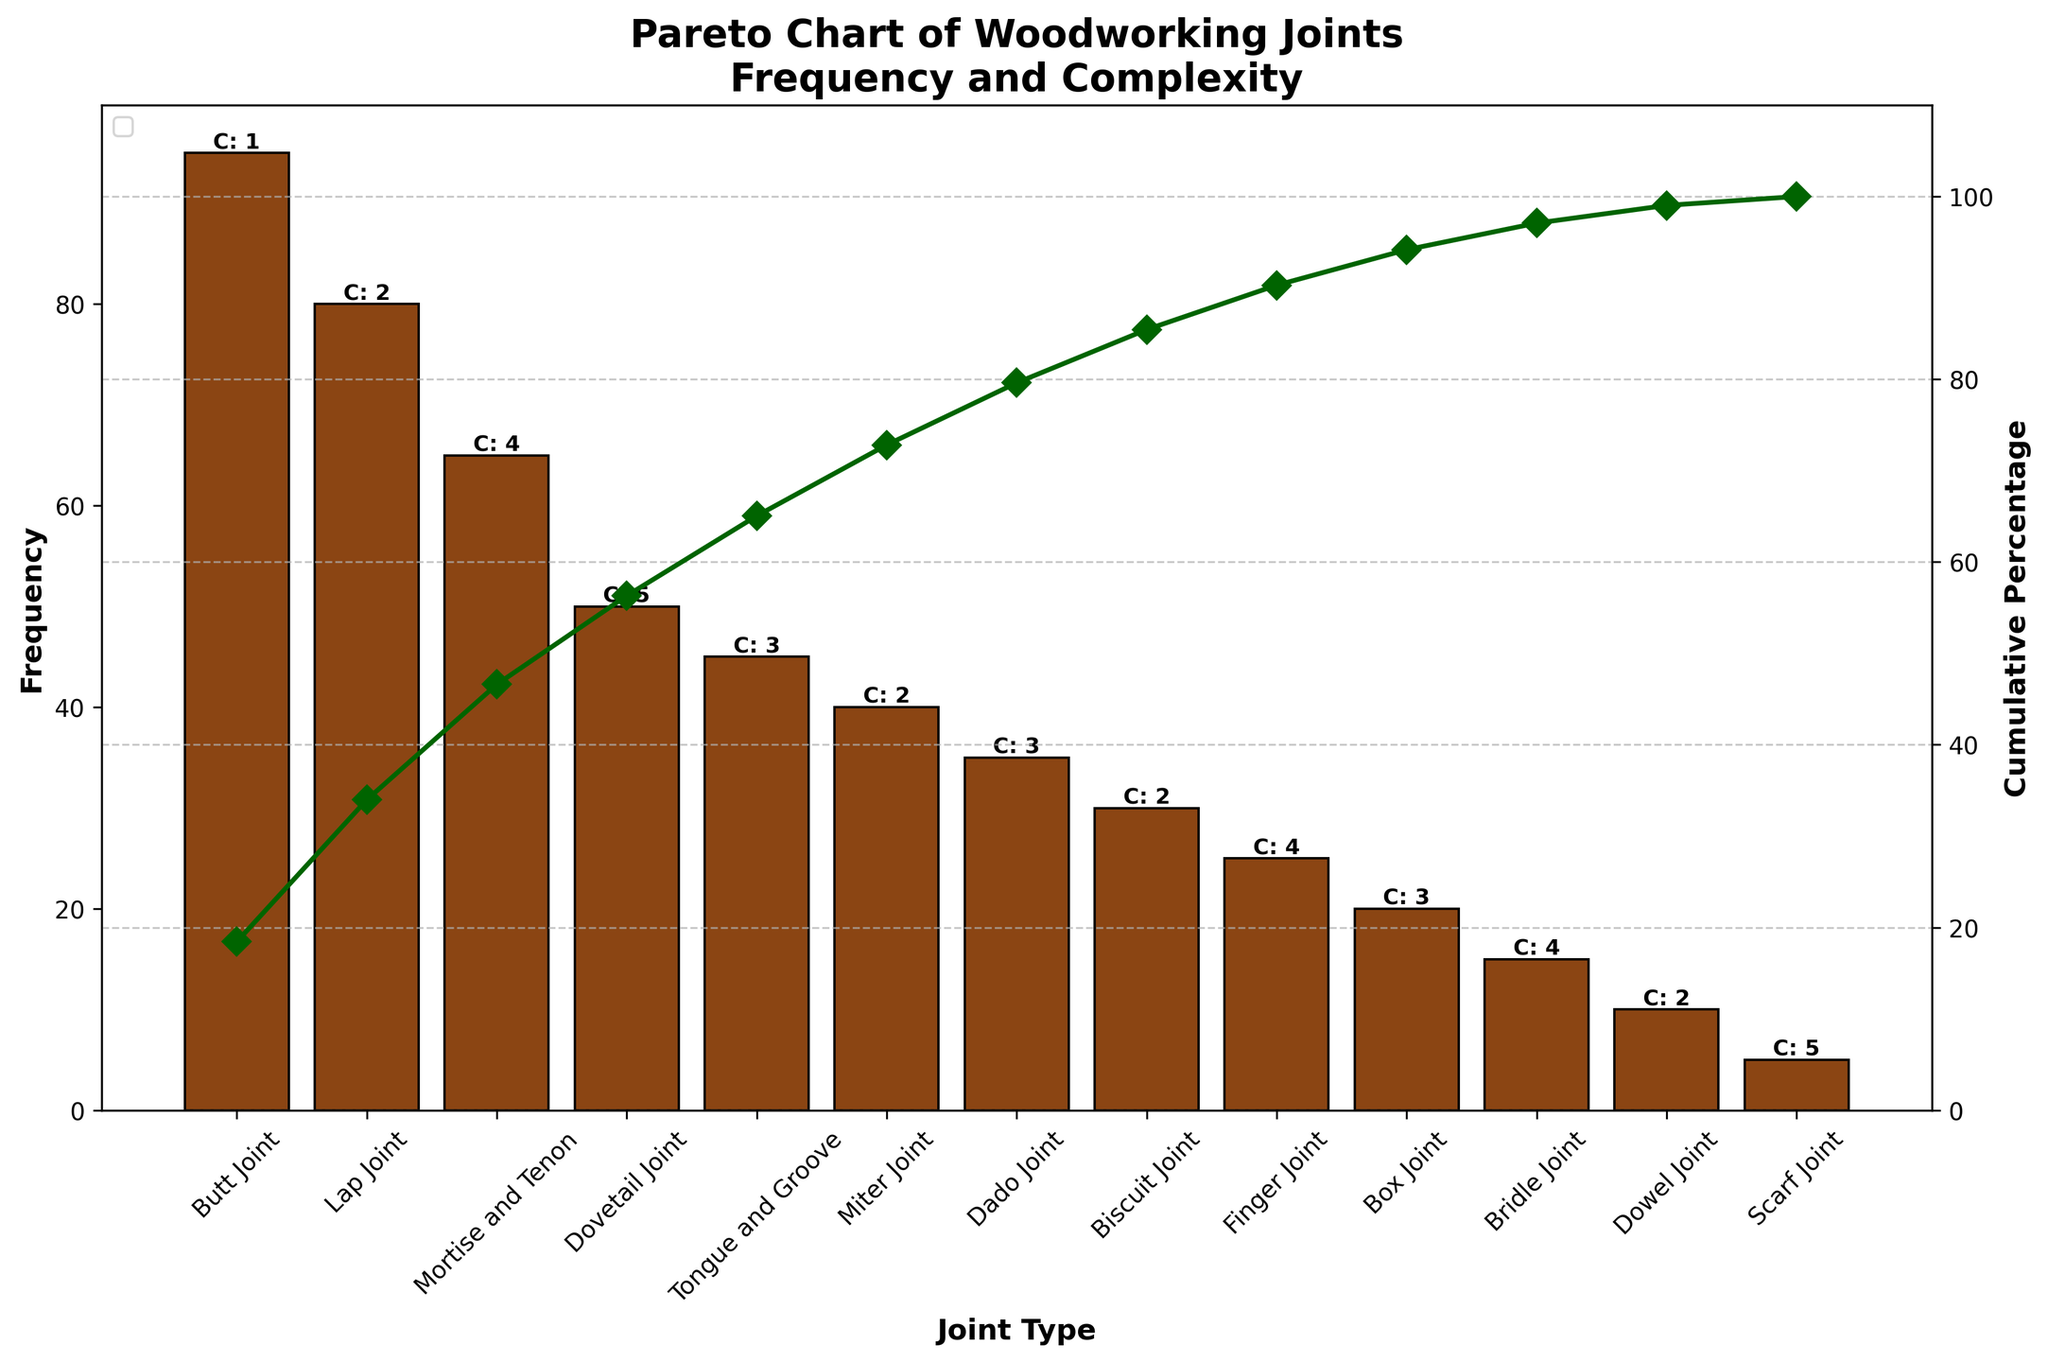What's the title of the chart? The title is displayed at the top of the chart and reads "Pareto Chart of Woodworking Joints\nFrequency and Complexity."
Answer: Pareto Chart of Woodworking Joints\nFrequency and Complexity How many types of joints are listed in the chart? The x-axis labels each joint type, and by counting them, you can determine there are 13 different types of joints listed.
Answer: 13 Which joint has the highest frequency of application? By looking at the heights of the bars on the chart, the Butt Joint has the highest bar, indicating it has the highest frequency of application.
Answer: Butt Joint What is the cumulative percentage for the Mortise and Tenon joint? Follow the cumulative percentage line and locate the point corresponding to the Mortise and Tenon joint. The line shows a cumulative percentage around 70%.
Answer: Approximately 70% Which joint type has the lowest frequency and what’s its value? The shortest bar corresponds to the Scarf Joint, which also shows its frequency value to be 5.
Answer: Scarf Joint, 5 What are the complexities associated with the highest and lowest frequency joints? The Butt Joint has the highest frequency with a complexity of 1, and the Scarf Joint has the lowest frequency with a complexity of 5.
Answer: 1 and 5 How many joints have a frequency above 50? Counting the bars taller than the 50-frequency mark, there are four joints: Butt Joint, Lap Joint, Mortise and Tenon, and Dovetail Joint.
Answer: 4 What’s the total frequency for Dovetail, Tongue and Groove, and Miter Joints combined? The frequencies for these joints are 50 (Dovetail), 45 (Tongue and Groove), and 40 (Miter), summing up to 50 + 45 + 40 = 135.
Answer: 135 How does the complexity of the Box Joint compare to the Biscuit Joint? By locating the bars for Box Joint and Biscuit Joint and reading the labeled complexities, the Box Joint has a complexity of 3 and the Biscuit Joint has a complexity of 2. Thus, the Box Joint has a higher complexity.
Answer: Box Joint has higher complexity Which joints have a complexity of 4, and what are their respective frequencies? Reading the labels for complexity under each bar, the joints with a complexity of 4 are Mortise and Tenon (65), Finger Joint (25), and Bridle Joint (15).
Answer: Mortise and Tenon (65), Finger Joint (25), Bridle Joint (15) 